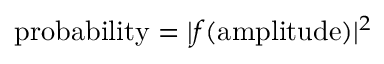<formula> <loc_0><loc_0><loc_500><loc_500>{ p r o b a b i l i t y } = | f ( { a m p l i t u d e } ) | ^ { 2 }</formula> 